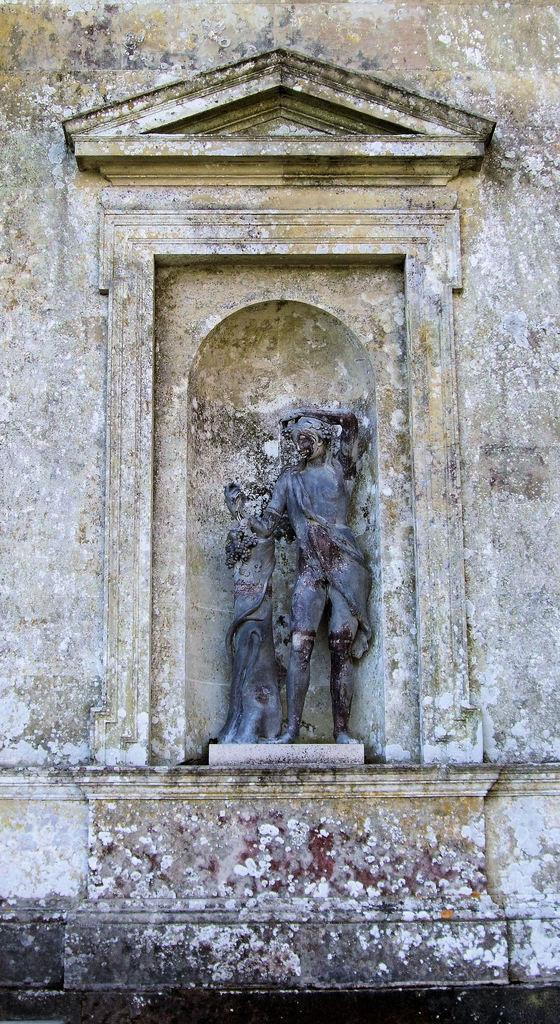What is the main subject of the image? The main subject of the image is a sculpture of a person. What is the sculpture doing in the image? The sculpture is standing in the image. What is the sculpture interacting with in the image? The sculpture has one hand placed on an object in the image. What can be seen surrounding the sculpture in the image? There is a designed wall around the sculpture in the image. What type of shock can be seen affecting the snake in the image? There is no snake present in the image, and therefore no shock can be observed. 